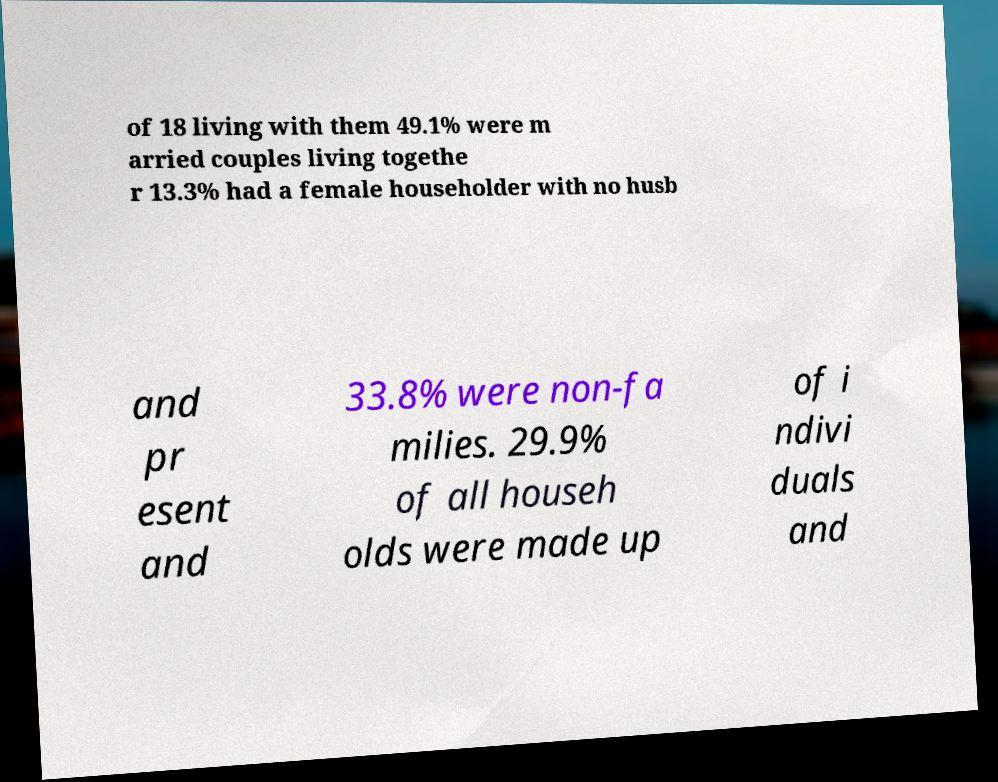Please identify and transcribe the text found in this image. of 18 living with them 49.1% were m arried couples living togethe r 13.3% had a female householder with no husb and pr esent and 33.8% were non-fa milies. 29.9% of all househ olds were made up of i ndivi duals and 